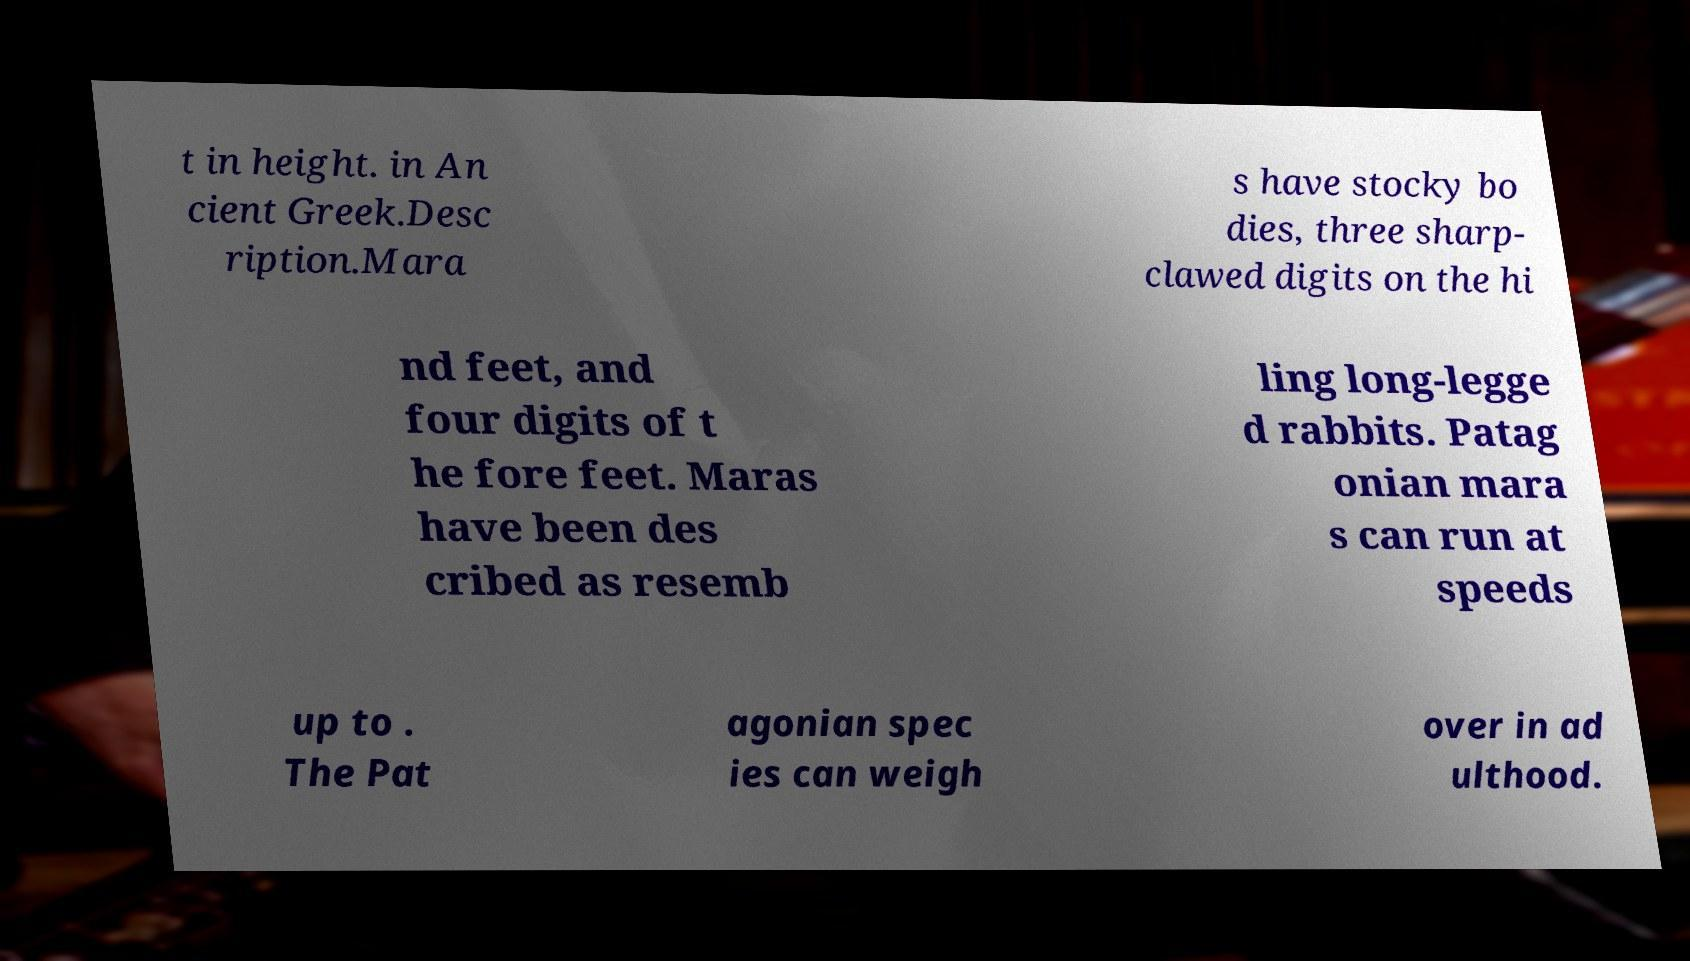Please identify and transcribe the text found in this image. t in height. in An cient Greek.Desc ription.Mara s have stocky bo dies, three sharp- clawed digits on the hi nd feet, and four digits of t he fore feet. Maras have been des cribed as resemb ling long-legge d rabbits. Patag onian mara s can run at speeds up to . The Pat agonian spec ies can weigh over in ad ulthood. 